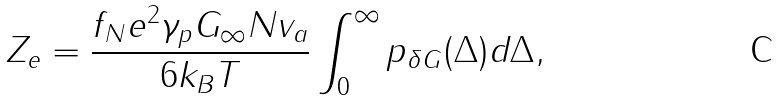Convert formula to latex. <formula><loc_0><loc_0><loc_500><loc_500>Z _ { e } = \frac { f _ { N } e ^ { 2 } \gamma _ { p } G _ { \infty } N v _ { a } } { 6 k _ { B } T } \int _ { 0 } ^ { \infty } p _ { \delta G } ( \Delta ) d \Delta ,</formula> 